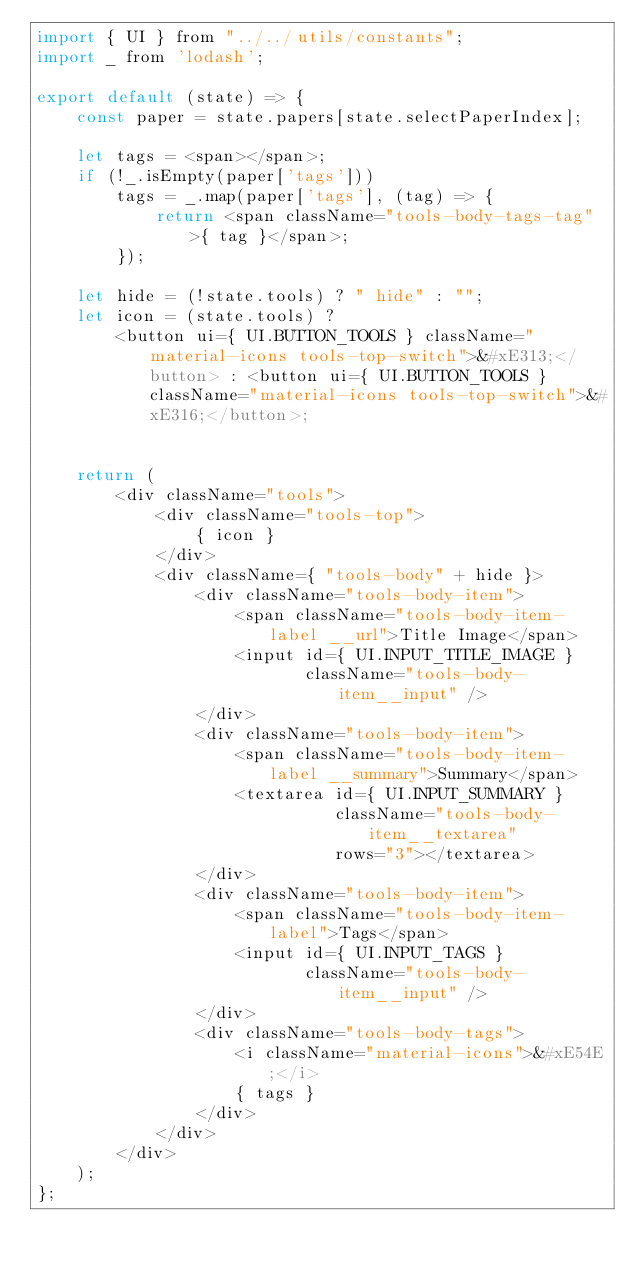Convert code to text. <code><loc_0><loc_0><loc_500><loc_500><_JavaScript_>import { UI } from "../../utils/constants";
import _ from 'lodash';

export default (state) => {
    const paper = state.papers[state.selectPaperIndex];
    
    let tags = <span></span>;
    if (!_.isEmpty(paper['tags']))
        tags = _.map(paper['tags'], (tag) => {
            return <span className="tools-body-tags-tag">{ tag }</span>;
        });
    
    let hide = (!state.tools) ? " hide" : "";
    let icon = (state.tools) ?
        <button ui={ UI.BUTTON_TOOLS } className="material-icons tools-top-switch">&#xE313;</button> : <button ui={ UI.BUTTON_TOOLS } className="material-icons tools-top-switch">&#xE316;</button>;


    return (
        <div className="tools">
            <div className="tools-top">
                { icon }
            </div>
            <div className={ "tools-body" + hide }>
                <div className="tools-body-item">
                    <span className="tools-body-item-label __url">Title Image</span>
                    <input id={ UI.INPUT_TITLE_IMAGE }
                           className="tools-body-item__input" />
                </div>
                <div className="tools-body-item">
                    <span className="tools-body-item-label __summary">Summary</span>
                    <textarea id={ UI.INPUT_SUMMARY }
                              className="tools-body-item__textarea"
                              rows="3"></textarea>
                </div>
                <div className="tools-body-item">
                    <span className="tools-body-item-label">Tags</span>
                    <input id={ UI.INPUT_TAGS }
                           className="tools-body-item__input" />
                </div>
                <div className="tools-body-tags">
                    <i className="material-icons">&#xE54E;</i>
                    { tags }
                </div>
            </div>
        </div>
    );
};</code> 